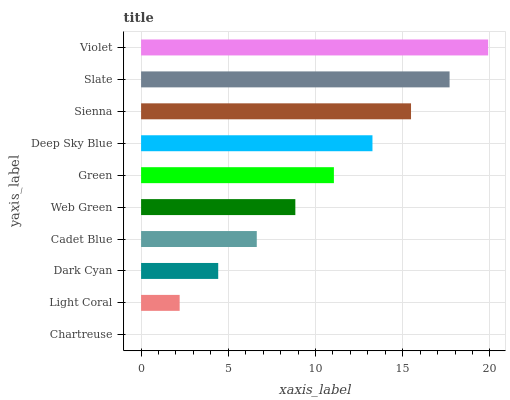Is Chartreuse the minimum?
Answer yes or no. Yes. Is Violet the maximum?
Answer yes or no. Yes. Is Light Coral the minimum?
Answer yes or no. No. Is Light Coral the maximum?
Answer yes or no. No. Is Light Coral greater than Chartreuse?
Answer yes or no. Yes. Is Chartreuse less than Light Coral?
Answer yes or no. Yes. Is Chartreuse greater than Light Coral?
Answer yes or no. No. Is Light Coral less than Chartreuse?
Answer yes or no. No. Is Green the high median?
Answer yes or no. Yes. Is Web Green the low median?
Answer yes or no. Yes. Is Dark Cyan the high median?
Answer yes or no. No. Is Cadet Blue the low median?
Answer yes or no. No. 